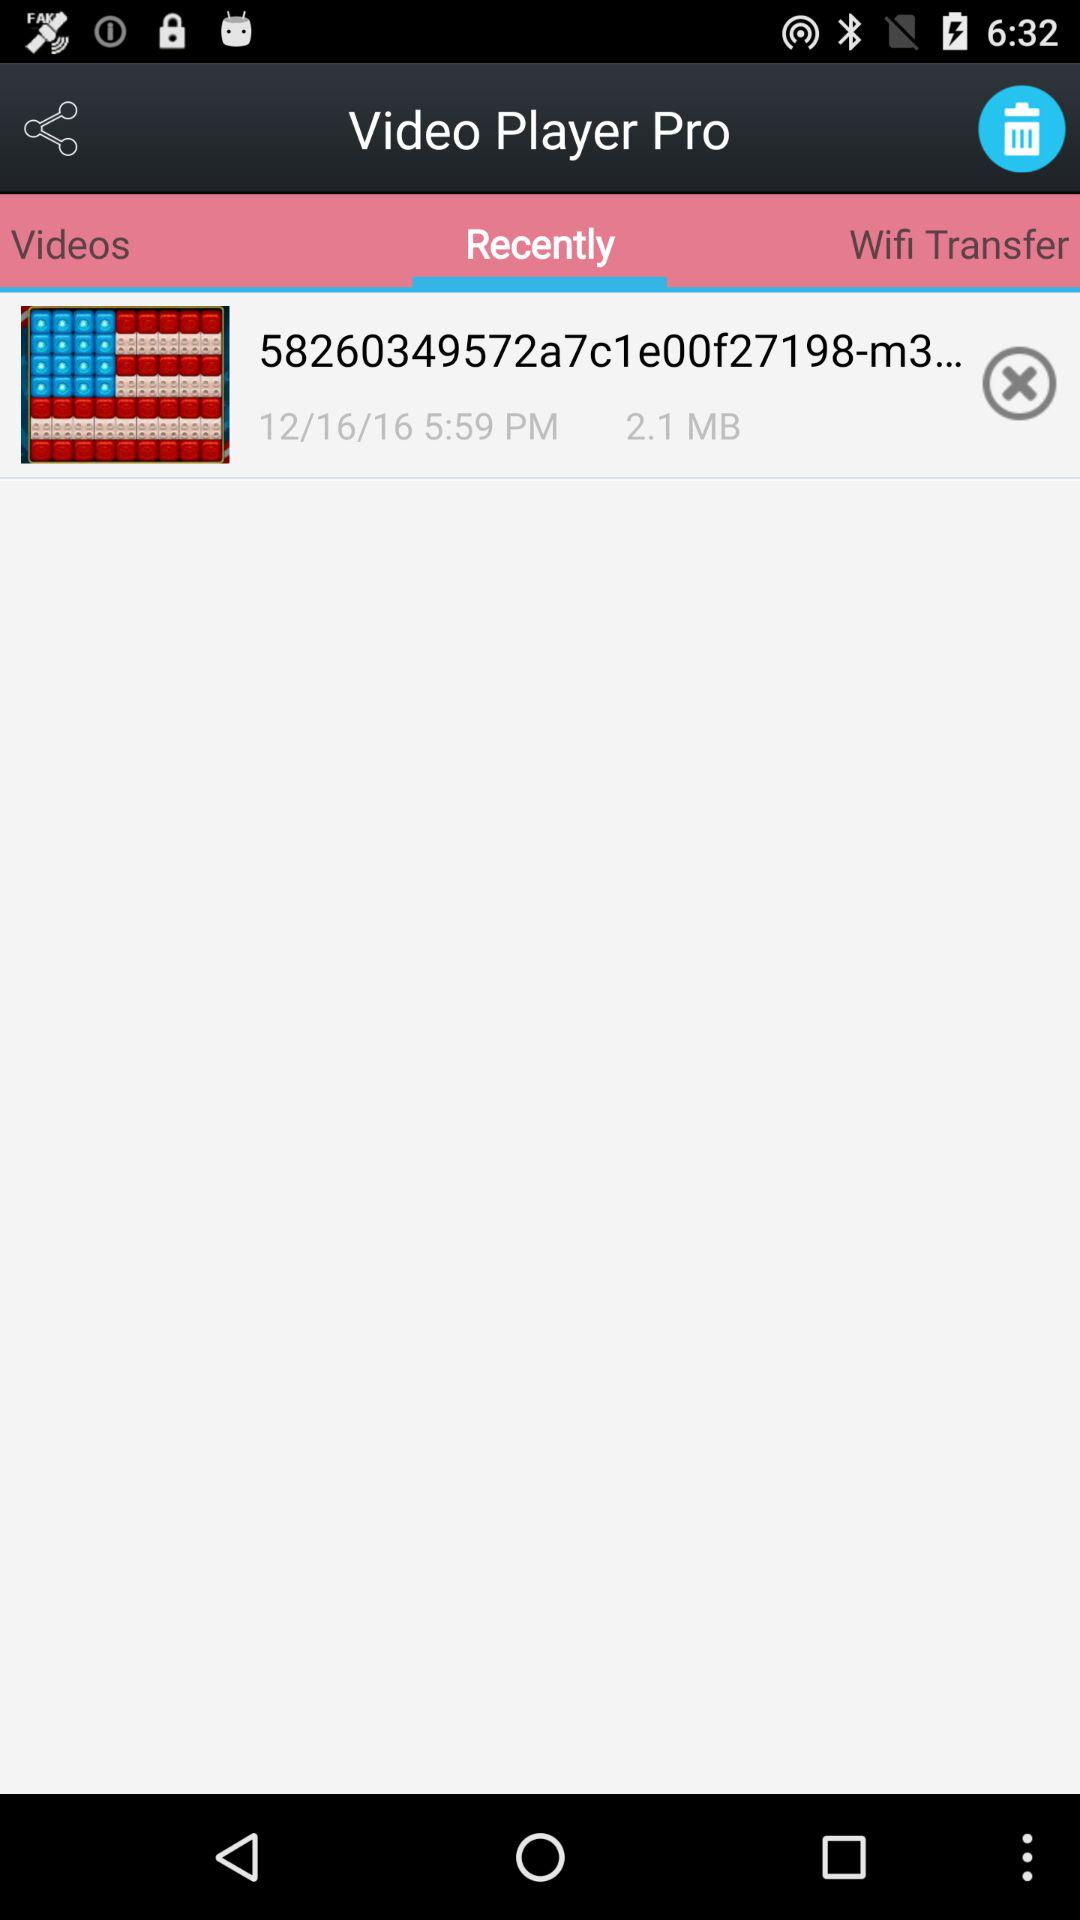What's the date of the video? The date is December 16, 2016. 